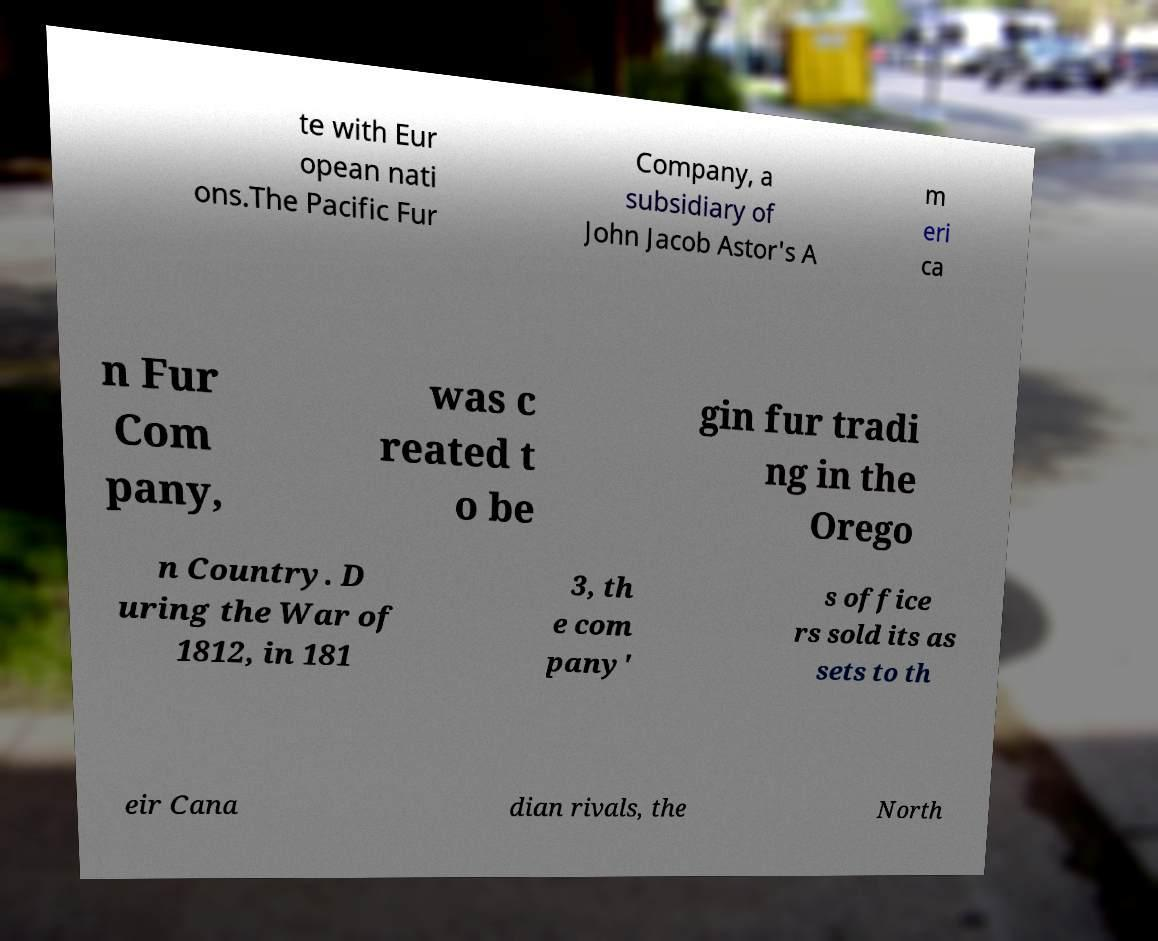Please identify and transcribe the text found in this image. te with Eur opean nati ons.The Pacific Fur Company, a subsidiary of John Jacob Astor's A m eri ca n Fur Com pany, was c reated t o be gin fur tradi ng in the Orego n Country. D uring the War of 1812, in 181 3, th e com pany' s office rs sold its as sets to th eir Cana dian rivals, the North 